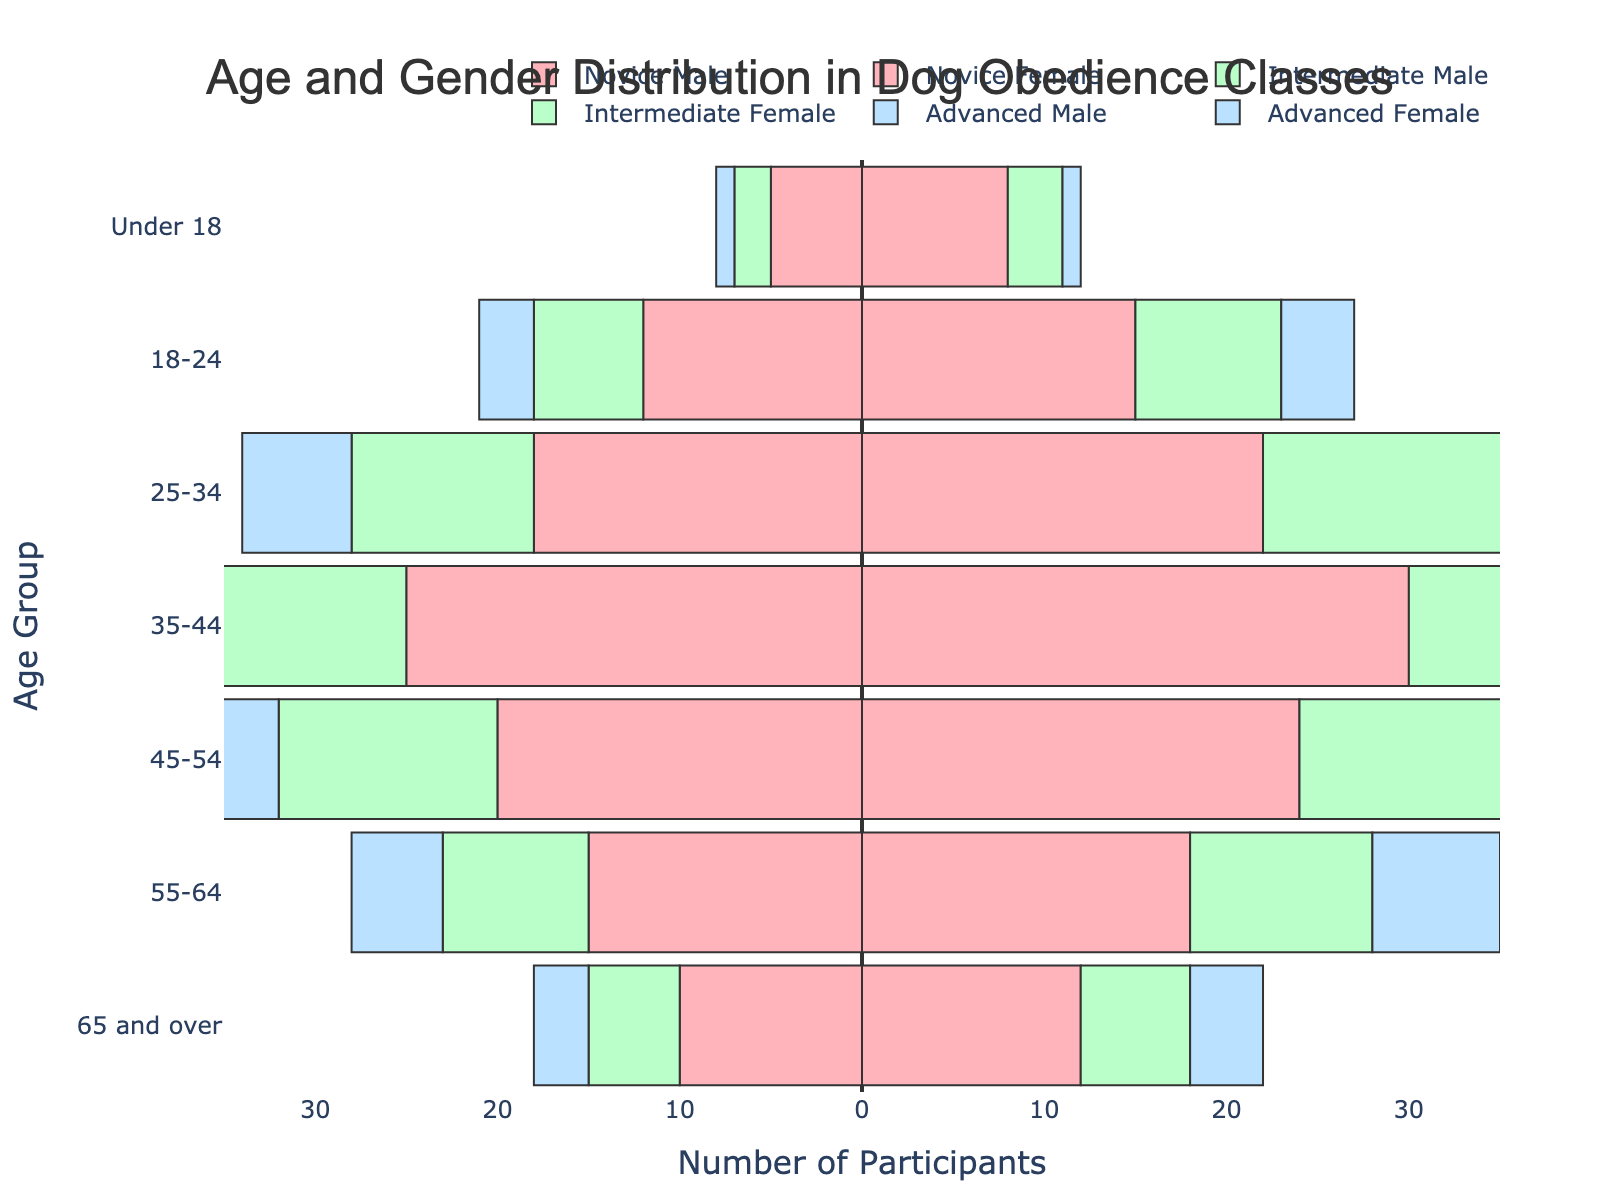What is the title of the figure? The title is usually located at the top of the figure. It provides a brief description of what the figure is about.
Answer: Age and Gender Distribution in Dog Obedience Classes Which age group has the highest number of Novice Female participants? By looking at the bars on the positive side for Novice Female, we compare the length of the bars for each age group. The longest bar represents the group with the highest count.
Answer: 35-44 How many more Intermediate Females are there in the 25-34 age group compared to Advanced Females in the same age group? Locate the bars representing Intermediate Females and Advanced Females for the 25-34 age group. The length of the bars indicates the number of participants. Subtract the Advanced Females count from the Intermediate Females count.
Answer: 6 Which age group shows the smallest difference between Novice Male and Novice Female participants? Calculate the absolute difference between Novice Male and Novice Female participants for each age group and find the smallest one.
Answer: 65 and over What is the total number of Advanced Male participants in all age groups? Sum the values for Advanced Male participants across all age groups. The counts are 1, 3, 6, 9, 8, 5, and 3. Add these together.
Answer: 35 Are there more Novice participants or Intermediate participants in the 18-24 age group? Sum the number of Novice (Male + Female) and Intermediate (Male + Female) participants in the 18-24 age group. Compare the two sums.
Answer: Novice Among the 45-54 age group, do more participants belong to the Advanced or Intermediate experience level? Compare the combined numbers of Male and Female participants for both Advanced and Intermediate levels within the 45-54 age group.
Answer: Intermediate Which gender has more participants in the 55-64 age group at the Novice experience level? Compare the number of Novice Male and Novice Female participants in the 55-64 age group.
Answer: Female What is the combined total of males and females across all age groups for the Intermediate experience level? Add the number of Intermediate Male and Female participants for each age group, then sum these totals together.
Answer: 92 In which age group is the number of participants most balanced between genders across all experience levels? For each age group, calculate the absolute difference between the total number of Male and Female participants across all three experience levels and find the smallest one.
Answer: 65 and over 